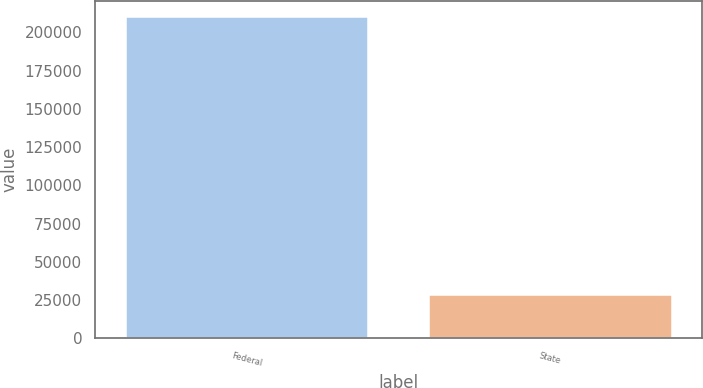Convert chart. <chart><loc_0><loc_0><loc_500><loc_500><bar_chart><fcel>Federal<fcel>State<nl><fcel>210327<fcel>28227<nl></chart> 